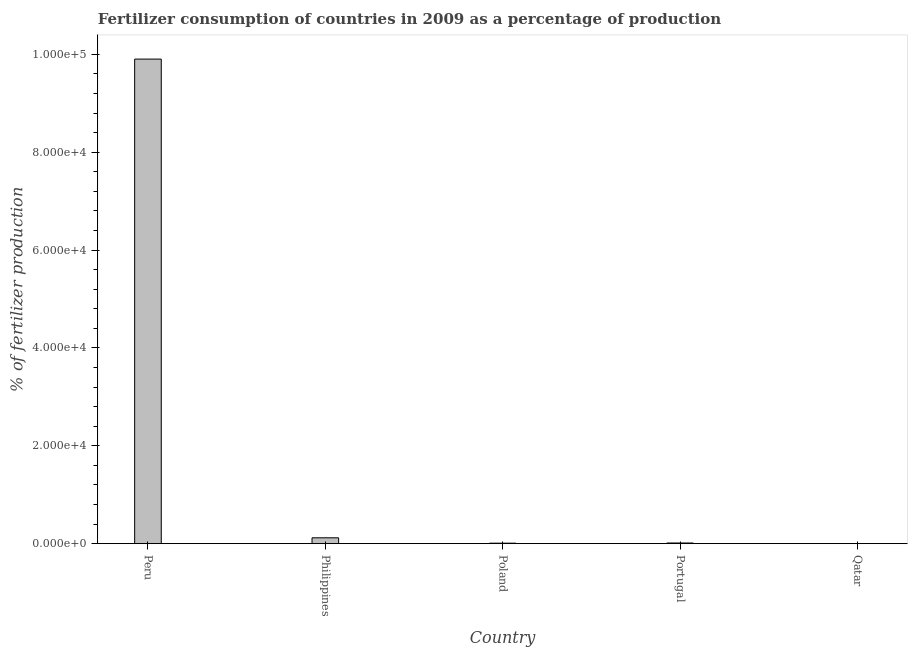What is the title of the graph?
Your answer should be very brief. Fertilizer consumption of countries in 2009 as a percentage of production. What is the label or title of the X-axis?
Keep it short and to the point. Country. What is the label or title of the Y-axis?
Ensure brevity in your answer.  % of fertilizer production. What is the amount of fertilizer consumption in Peru?
Make the answer very short. 9.90e+04. Across all countries, what is the maximum amount of fertilizer consumption?
Offer a terse response. 9.90e+04. Across all countries, what is the minimum amount of fertilizer consumption?
Give a very brief answer. 2.78. In which country was the amount of fertilizer consumption minimum?
Your answer should be very brief. Qatar. What is the sum of the amount of fertilizer consumption?
Offer a terse response. 1.00e+05. What is the difference between the amount of fertilizer consumption in Philippines and Qatar?
Give a very brief answer. 1194.37. What is the average amount of fertilizer consumption per country?
Offer a very short reply. 2.01e+04. What is the median amount of fertilizer consumption?
Offer a terse response. 136.43. What is the ratio of the amount of fertilizer consumption in Poland to that in Qatar?
Your answer should be very brief. 35.82. Is the amount of fertilizer consumption in Peru less than that in Poland?
Your answer should be compact. No. Is the difference between the amount of fertilizer consumption in Peru and Portugal greater than the difference between any two countries?
Make the answer very short. No. What is the difference between the highest and the second highest amount of fertilizer consumption?
Ensure brevity in your answer.  9.78e+04. Is the sum of the amount of fertilizer consumption in Peru and Poland greater than the maximum amount of fertilizer consumption across all countries?
Your response must be concise. Yes. What is the difference between the highest and the lowest amount of fertilizer consumption?
Make the answer very short. 9.90e+04. Are all the bars in the graph horizontal?
Your answer should be compact. No. How many countries are there in the graph?
Provide a succinct answer. 5. What is the difference between two consecutive major ticks on the Y-axis?
Your response must be concise. 2.00e+04. What is the % of fertilizer production in Peru?
Offer a very short reply. 9.90e+04. What is the % of fertilizer production of Philippines?
Your answer should be very brief. 1197.15. What is the % of fertilizer production in Poland?
Give a very brief answer. 99.49. What is the % of fertilizer production of Portugal?
Make the answer very short. 136.43. What is the % of fertilizer production of Qatar?
Keep it short and to the point. 2.78. What is the difference between the % of fertilizer production in Peru and Philippines?
Offer a terse response. 9.78e+04. What is the difference between the % of fertilizer production in Peru and Poland?
Make the answer very short. 9.89e+04. What is the difference between the % of fertilizer production in Peru and Portugal?
Offer a terse response. 9.89e+04. What is the difference between the % of fertilizer production in Peru and Qatar?
Ensure brevity in your answer.  9.90e+04. What is the difference between the % of fertilizer production in Philippines and Poland?
Provide a succinct answer. 1097.66. What is the difference between the % of fertilizer production in Philippines and Portugal?
Keep it short and to the point. 1060.72. What is the difference between the % of fertilizer production in Philippines and Qatar?
Your response must be concise. 1194.37. What is the difference between the % of fertilizer production in Poland and Portugal?
Offer a very short reply. -36.94. What is the difference between the % of fertilizer production in Poland and Qatar?
Provide a succinct answer. 96.71. What is the difference between the % of fertilizer production in Portugal and Qatar?
Give a very brief answer. 133.65. What is the ratio of the % of fertilizer production in Peru to that in Philippines?
Offer a terse response. 82.72. What is the ratio of the % of fertilizer production in Peru to that in Poland?
Make the answer very short. 995.35. What is the ratio of the % of fertilizer production in Peru to that in Portugal?
Make the answer very short. 725.83. What is the ratio of the % of fertilizer production in Peru to that in Qatar?
Offer a terse response. 3.57e+04. What is the ratio of the % of fertilizer production in Philippines to that in Poland?
Provide a short and direct response. 12.03. What is the ratio of the % of fertilizer production in Philippines to that in Portugal?
Offer a terse response. 8.78. What is the ratio of the % of fertilizer production in Philippines to that in Qatar?
Ensure brevity in your answer.  431.06. What is the ratio of the % of fertilizer production in Poland to that in Portugal?
Provide a succinct answer. 0.73. What is the ratio of the % of fertilizer production in Poland to that in Qatar?
Your response must be concise. 35.82. What is the ratio of the % of fertilizer production in Portugal to that in Qatar?
Provide a succinct answer. 49.12. 